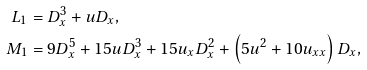Convert formula to latex. <formula><loc_0><loc_0><loc_500><loc_500>L _ { 1 } & = D _ { x } ^ { 3 } + u D _ { x } , \\ M _ { 1 } & = 9 D _ { x } ^ { 5 } + 1 5 u D _ { x } ^ { 3 } + 1 5 u _ { x } D _ { x } ^ { 2 } + \left ( 5 u ^ { 2 } + 1 0 u _ { x x } \right ) D _ { x } ,</formula> 